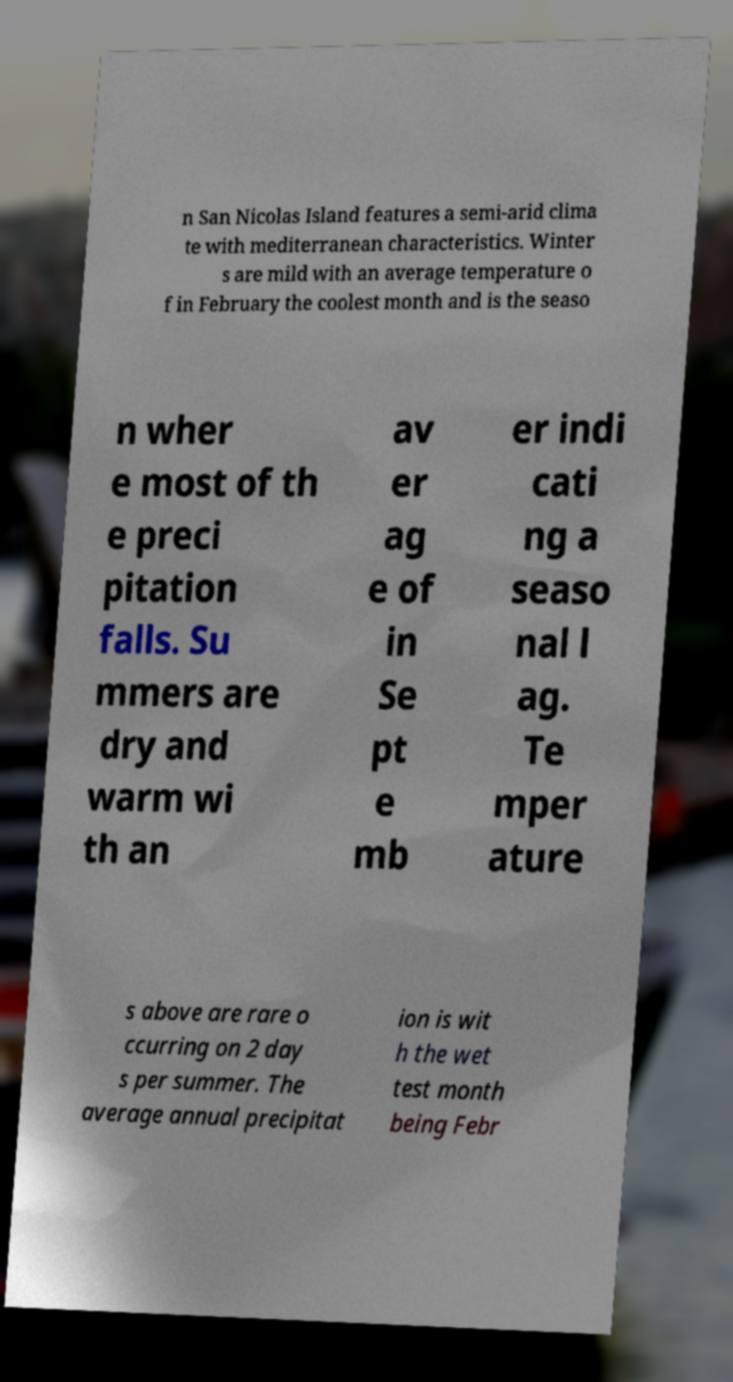There's text embedded in this image that I need extracted. Can you transcribe it verbatim? n San Nicolas Island features a semi-arid clima te with mediterranean characteristics. Winter s are mild with an average temperature o f in February the coolest month and is the seaso n wher e most of th e preci pitation falls. Su mmers are dry and warm wi th an av er ag e of in Se pt e mb er indi cati ng a seaso nal l ag. Te mper ature s above are rare o ccurring on 2 day s per summer. The average annual precipitat ion is wit h the wet test month being Febr 